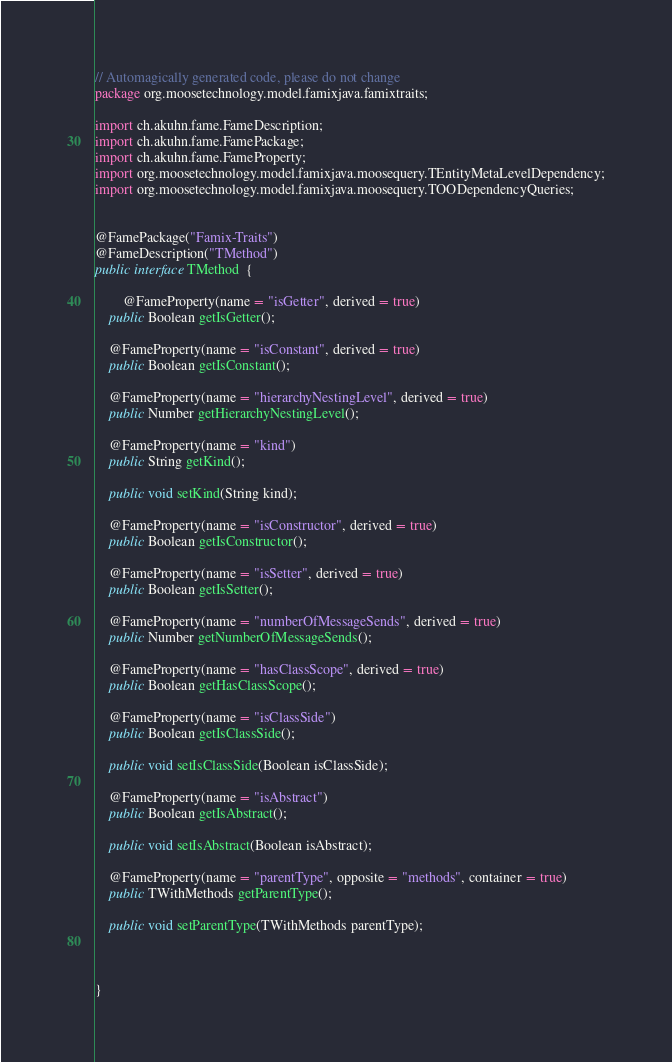<code> <loc_0><loc_0><loc_500><loc_500><_Java_>// Automagically generated code, please do not change
package org.moosetechnology.model.famixjava.famixtraits;

import ch.akuhn.fame.FameDescription;
import ch.akuhn.fame.FamePackage;
import ch.akuhn.fame.FameProperty;
import org.moosetechnology.model.famixjava.moosequery.TEntityMetaLevelDependency;
import org.moosetechnology.model.famixjava.moosequery.TOODependencyQueries;


@FamePackage("Famix-Traits")
@FameDescription("TMethod")
public interface TMethod  {

        @FameProperty(name = "isGetter", derived = true)
    public Boolean getIsGetter();

    @FameProperty(name = "isConstant", derived = true)
    public Boolean getIsConstant();

    @FameProperty(name = "hierarchyNestingLevel", derived = true)
    public Number getHierarchyNestingLevel();

    @FameProperty(name = "kind")
    public String getKind();

    public void setKind(String kind);

    @FameProperty(name = "isConstructor", derived = true)
    public Boolean getIsConstructor();

    @FameProperty(name = "isSetter", derived = true)
    public Boolean getIsSetter();

    @FameProperty(name = "numberOfMessageSends", derived = true)
    public Number getNumberOfMessageSends();

    @FameProperty(name = "hasClassScope", derived = true)
    public Boolean getHasClassScope();

    @FameProperty(name = "isClassSide")
    public Boolean getIsClassSide();

    public void setIsClassSide(Boolean isClassSide);

    @FameProperty(name = "isAbstract")
    public Boolean getIsAbstract();

    public void setIsAbstract(Boolean isAbstract);

    @FameProperty(name = "parentType", opposite = "methods", container = true)
    public TWithMethods getParentType();

    public void setParentType(TWithMethods parentType);



}

</code> 